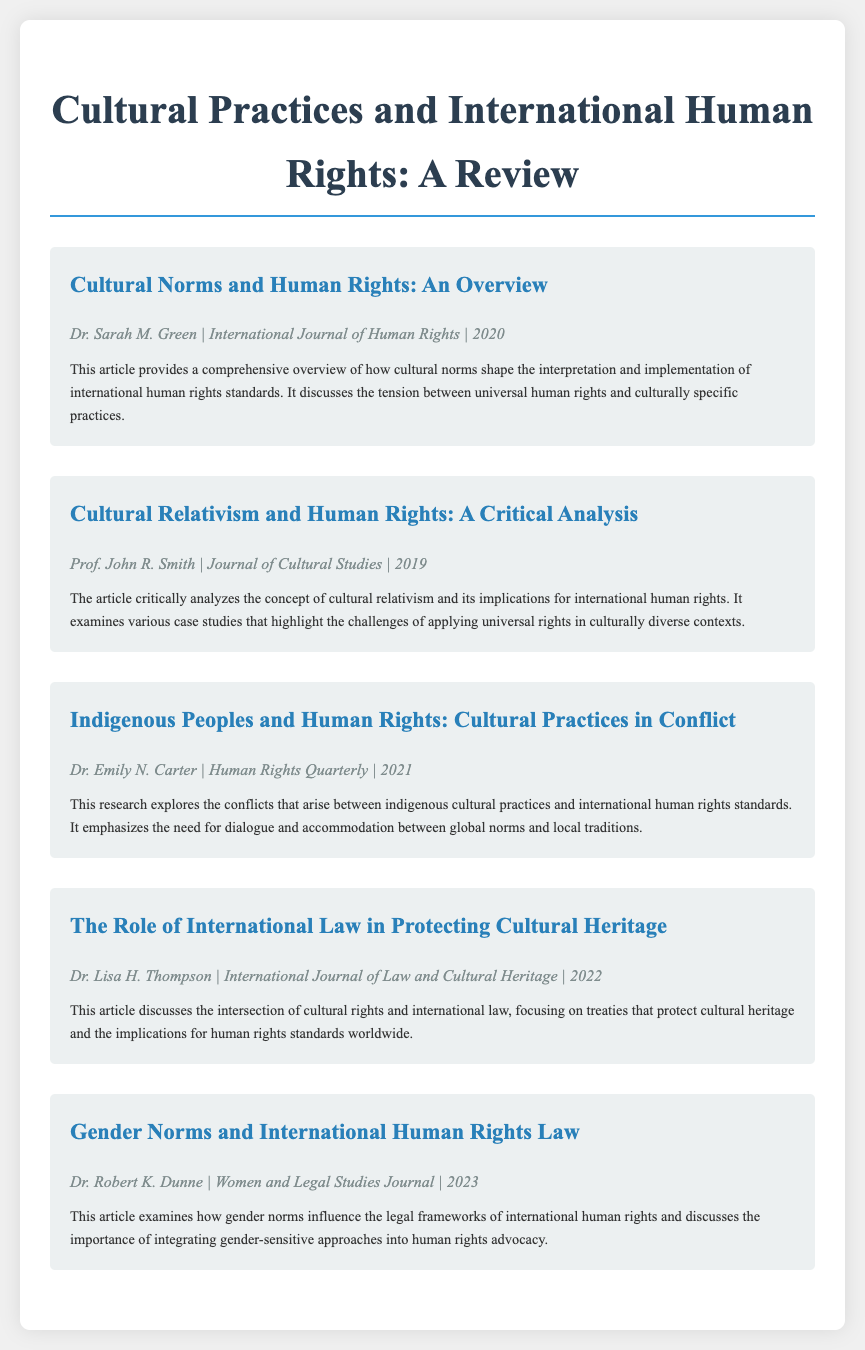what is the title of the first article? The title of the first article is the heading of the article section in the document.
Answer: Cultural Norms and Human Rights: An Overview who is the author of the article on cultural relativism? The author is listed below the title of each article, identifying the contributor.
Answer: Prof. John R. Smith which journal published the article on indigenous people and human rights? The journal name is included in the article metadata, providing information about where it was published.
Answer: Human Rights Quarterly how many articles are included in the document? The total number of articles can be counted by the number of article sections present in the document.
Answer: 5 what year was the article on gender norms published? The publication year is part of the article metadata, indicating when the research was released.
Answer: 2023 what is a key focus of Dr. Lisa H. Thompson's article? The key focus can be inferred from the article summary, highlighting the main theme of the research presented.
Answer: Protecting cultural heritage what does the summary of Dr. Emily N. Carter's article emphasize? The emphasis is usually captured within the article summary, revealing the core argument or finding of the study.
Answer: Dialogue and accommodation which article discusses the relationship between gender norms and international human rights law? The question targets the content of the articles based on their titles.
Answer: Gender Norms and International Human Rights Law who is the author of the article that provides an overview of cultural norms? Authors are clearly stated in the article metadata beneath each title.
Answer: Dr. Sarah M. Green 